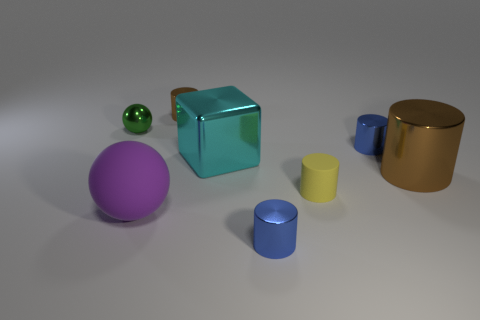Is the color of the small metallic cylinder that is in front of the cyan thing the same as the small matte cylinder that is on the right side of the metal ball?
Your response must be concise. No. What shape is the tiny yellow matte object?
Your answer should be very brief. Cylinder. How many cyan shiny cubes are in front of the green sphere?
Provide a short and direct response. 1. How many small gray things are made of the same material as the purple object?
Your response must be concise. 0. Are the brown cylinder that is in front of the shiny sphere and the yellow thing made of the same material?
Make the answer very short. No. Are any small brown rubber cubes visible?
Offer a very short reply. No. There is a cylinder that is behind the large brown metal thing and in front of the green ball; how big is it?
Make the answer very short. Small. Are there more small metal balls in front of the big purple matte thing than big purple balls that are right of the large block?
Your response must be concise. No. The other cylinder that is the same color as the large cylinder is what size?
Your answer should be compact. Small. What is the color of the large block?
Offer a very short reply. Cyan. 